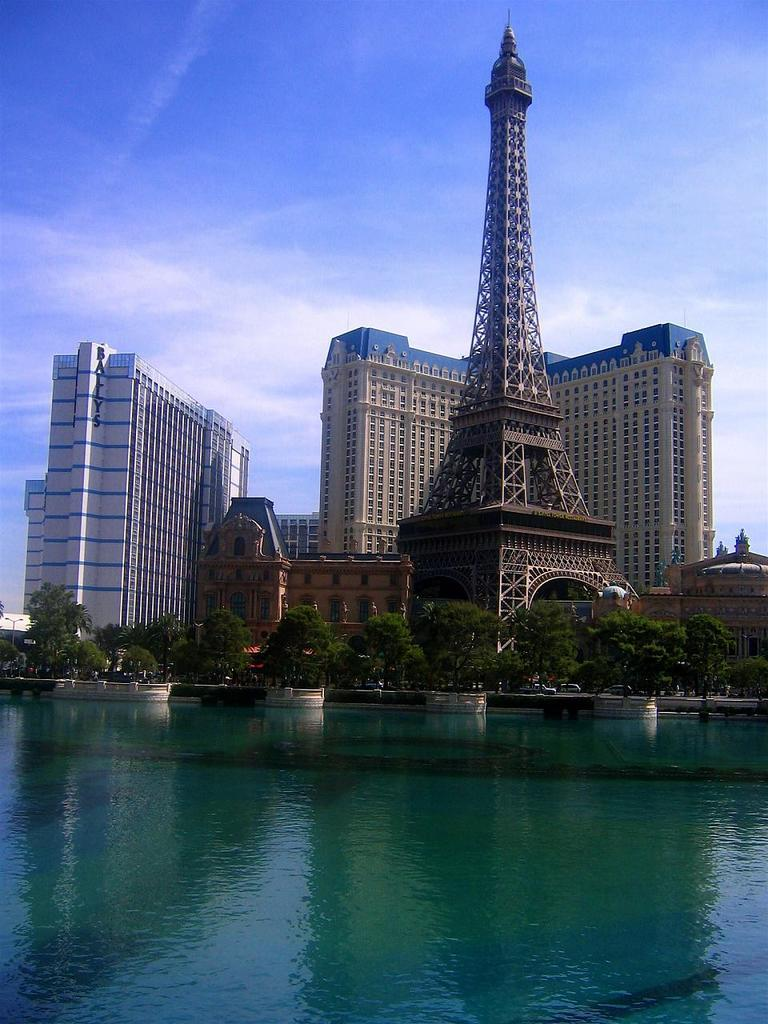What type of natural feature is present in the image? There is a lake in the image. What can be seen in the background of the image? There are trees, a tower, and buildings in the background of the image. What is the condition of the sky in the image? The sky is clear in the image. Can you tell me how many dolls are sitting on the uncle's territory in the image? There is no uncle, doll, or territory present in the image. 